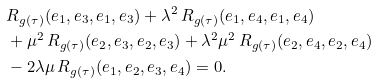<formula> <loc_0><loc_0><loc_500><loc_500>& R _ { g ( \tau ) } ( e _ { 1 } , e _ { 3 } , e _ { 1 } , e _ { 3 } ) + \lambda ^ { 2 } \, R _ { g ( \tau ) } ( e _ { 1 } , e _ { 4 } , e _ { 1 } , e _ { 4 } ) \\ & + \mu ^ { 2 } \, R _ { g ( \tau ) } ( e _ { 2 } , e _ { 3 } , e _ { 2 } , e _ { 3 } ) + \lambda ^ { 2 } \mu ^ { 2 } \, R _ { g ( \tau ) } ( e _ { 2 } , e _ { 4 } , e _ { 2 } , e _ { 4 } ) \\ & - 2 \lambda \mu \, R _ { g ( \tau ) } ( e _ { 1 } , e _ { 2 } , e _ { 3 } , e _ { 4 } ) = 0 .</formula> 